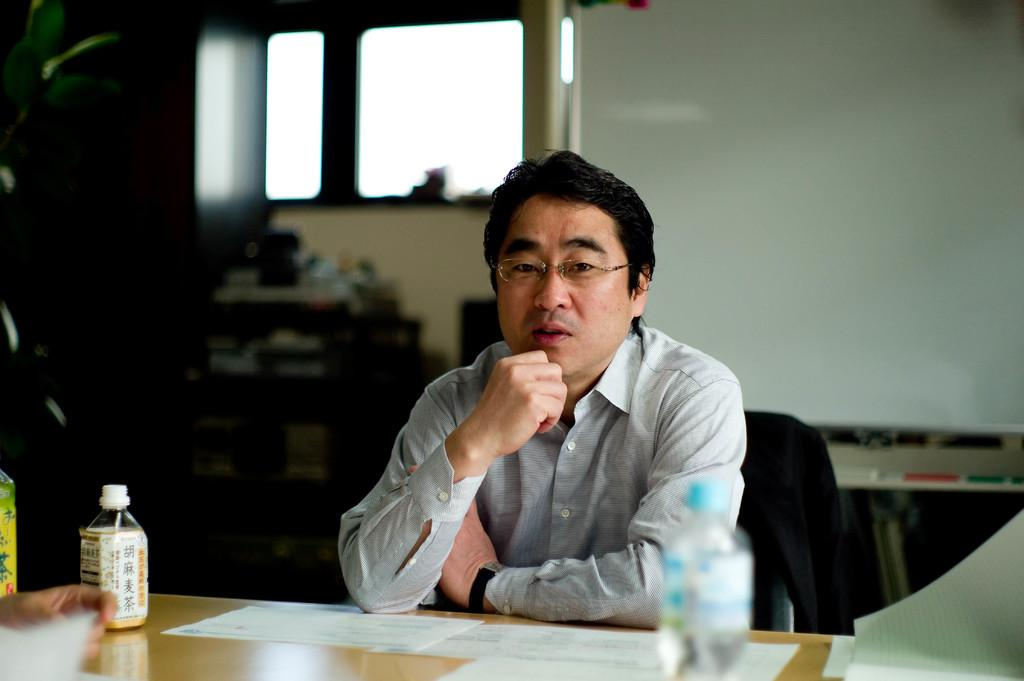What is the man in the image doing? The man is sitting on a chair in the image. What is the man doing with his hands? The man has his hands on a table in the image. What objects are on the table? There are bottles and papers on the table in the image. What can be seen in the background of the image? There is a window and a screen in the background of the image. What type of grain is growing in the image? There is no grain present in the image. How many frogs can be seen interacting with the man in the image? There are no frogs present in the image. 